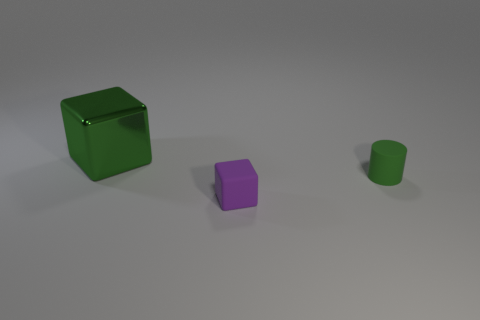Is there anything else that has the same size as the green cylinder?
Keep it short and to the point. Yes. There is a small thing that is made of the same material as the small cylinder; what is its color?
Offer a very short reply. Purple. Is the big metallic thing the same shape as the green matte thing?
Your answer should be compact. No. What number of objects are both to the left of the green matte cylinder and behind the tiny cube?
Give a very brief answer. 1. How many matte things are either tiny red cubes or big green things?
Offer a terse response. 0. How big is the shiny block left of the tiny object that is behind the tiny purple object?
Give a very brief answer. Large. There is a small object that is the same color as the metal block; what material is it?
Ensure brevity in your answer.  Rubber. There is a green object that is behind the matte object on the right side of the purple rubber object; are there any green matte things to the left of it?
Ensure brevity in your answer.  No. Is the material of the green object that is on the right side of the large shiny object the same as the thing that is to the left of the tiny purple thing?
Your answer should be very brief. No. What number of objects are large red objects or cubes that are behind the cylinder?
Ensure brevity in your answer.  1. 